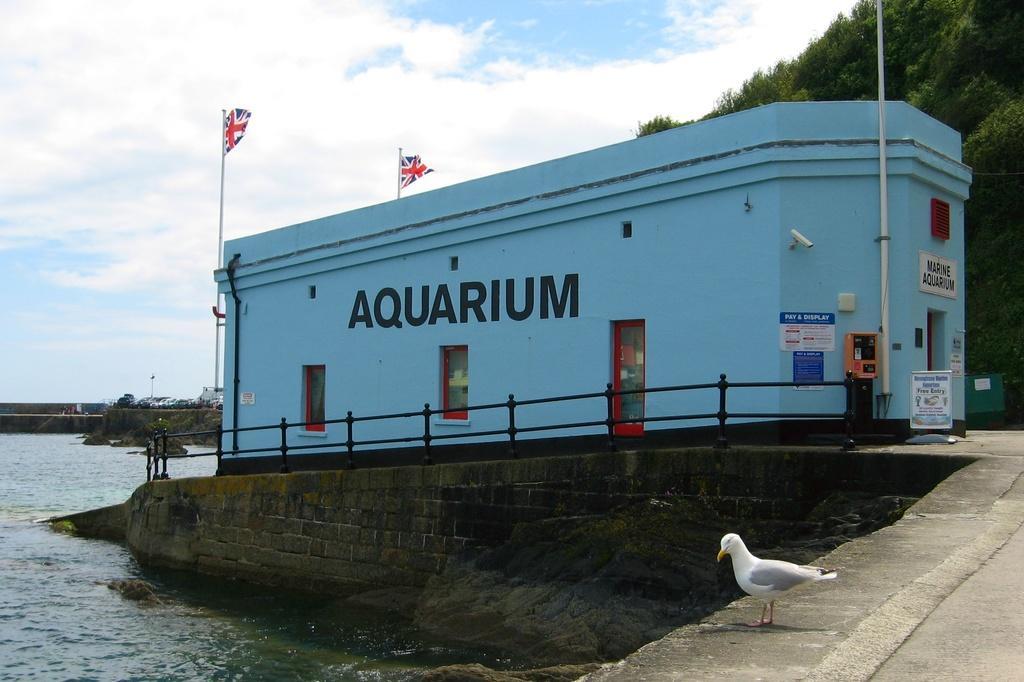Can you describe this image briefly? In this image I can see a bird which is in white color, background I can see a building in blue color. I can also see two flags, they are in red, blue and white color, trees in green color, water and the sky is in white and blue color. 